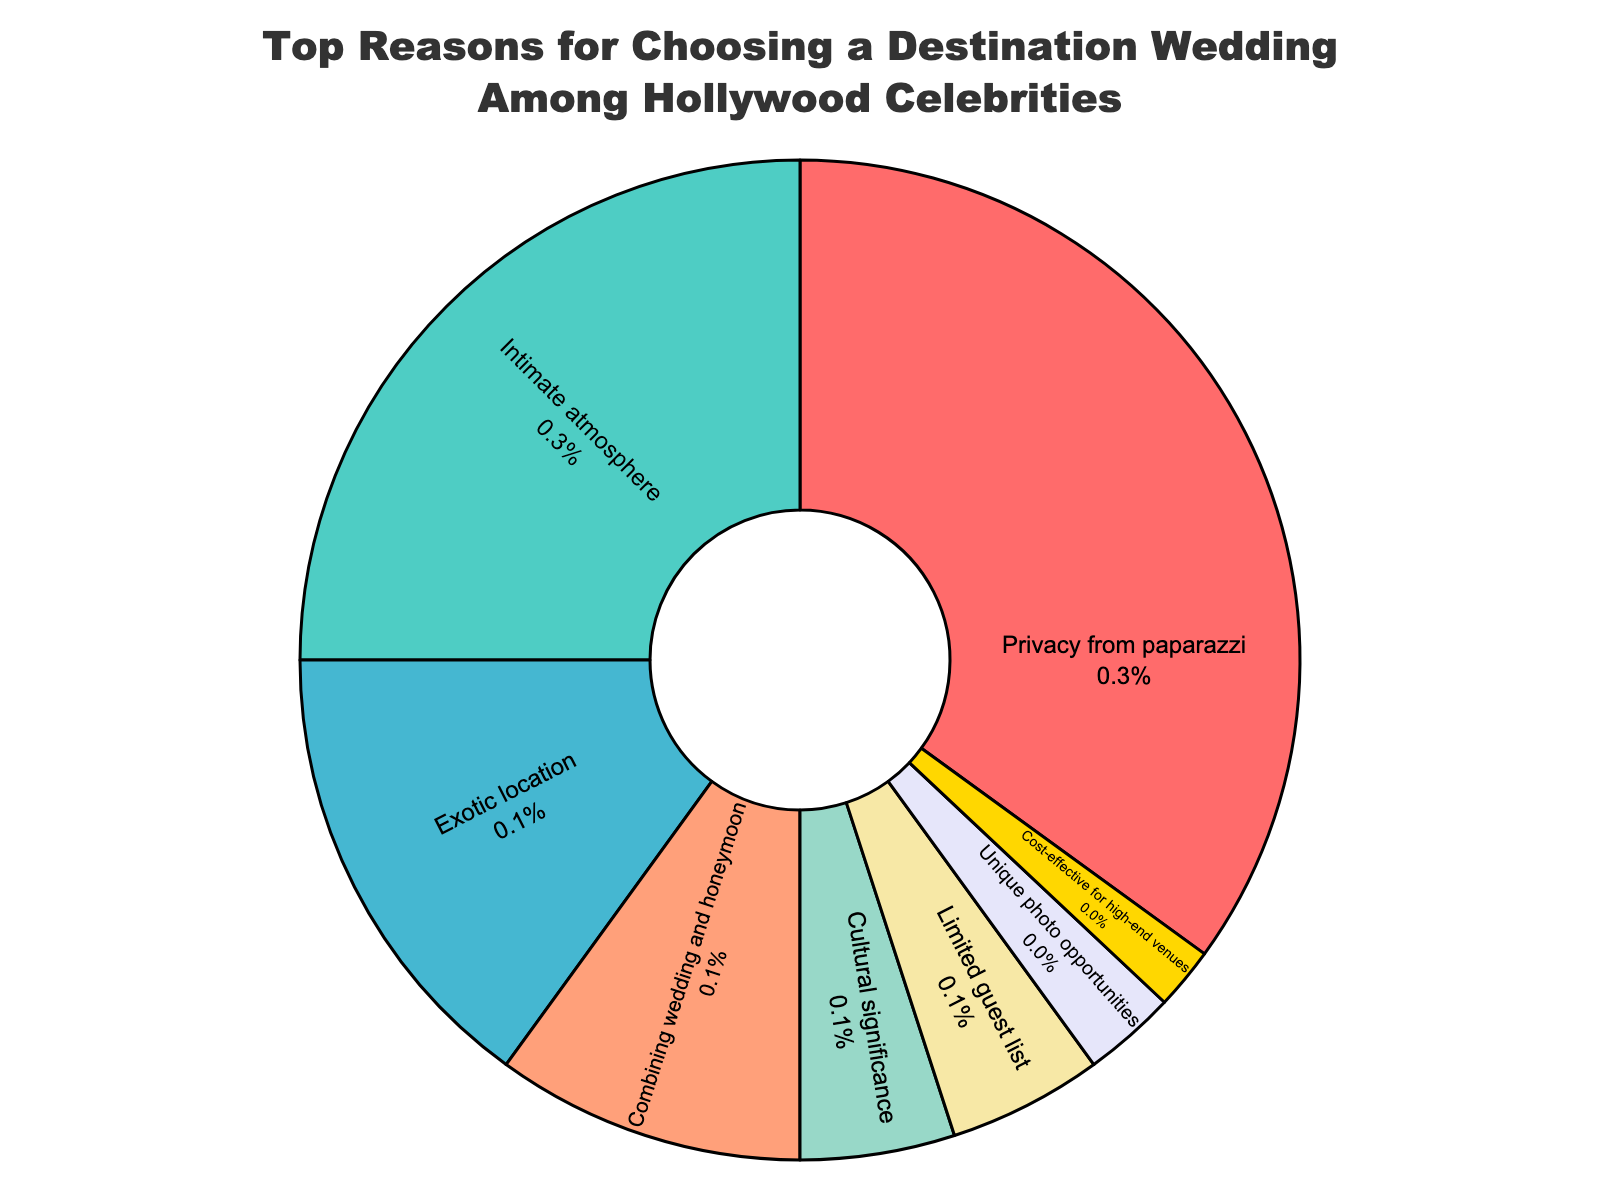Which reason is the most popular for Hollywood celebrities choosing a destination wedding? The pie chart shows that the segment with the largest percentage is for the reason "Privacy from paparazzi" with 35%. Therefore, this is the most popular reason among Hollywood celebrities.
Answer: Privacy from paparazzi What percentage of Hollywood celebrities choose a destination wedding for an intimate atmosphere? To find this information, refer to the slice in the pie chart labeled "Intimate atmosphere" which has the percentage value next to it. The value shown is 25%.
Answer: 25% How do the reasons "Combining wedding and honeymoon" and "Cultural significance" together compare to "Privacy from paparazzi" in terms of popularity? To compare the combined percentage of "Combining wedding and honeymoon" and "Cultural significance" to "Privacy from paparazzi", first sum their percentages: 10% + 5% = 15%. "Privacy from paparazzi" has 35%, which is more than the combined 15%.
Answer: Privacy from paparazzi is more popular What is the difference in popularity between "Exotic location" and "Limited guest list"? Locate the percentages for "Exotic location" (15%) and "Limited guest list" (5%). The difference is found by subtracting the smaller percentage from the larger one: 15% - 5% = 10%.
Answer: 10% Which two reasons have the least popularity, and what are their combined percentages? The chart shows "Unique photo opportunities" at 3% and "Cost-effective for high-end venues" at 2% as the smallest segments. Their combined percentage is 3% + 2% = 5%.
Answer: Unique photo opportunities and Cost-effective for high-end venues; 5% Are there more celebrities choosing a destination wedding for "Cultural significance" than for "Combining wedding and honeymoon"? Refer to the chart to find the percentages: "Cultural significance" is at 5% and "Combining wedding and honeymoon" is at 10%. Since 10% is greater than 5%, more celebrities choose it for combining wedding and honeymoon.
Answer: No What is the average percentage of the four least popular reasons? Identify the four least popular reasons: "Cultural significance" (5%), "Limited guest list" (5%), "Unique photo opportunities" (3%), and "Cost-effective for high-end venues" (2%). Sum these percentages: 5 + 5 + 3 + 2 = 15. Divide by 4 to get the average: 15 / 4 = 3.75%.
Answer: 3.75% How does the popularity of "Privacy from paparazzi" compare to the cumulative percentage of reasons with less than 10%? Sum the percentages of reasons with less than 10%: "Cultural significance" (5%), "Limited guest list" (5%), "Unique photo opportunities" (3%), and "Cost-effective for high-end venues" (2%). This gives 5 + 5 + 3 + 2 = 15%. As "Privacy from paparazzi" is 35%, 35% is more than the cumulative 15%.
Answer: Privacy from paparazzi is more popular 